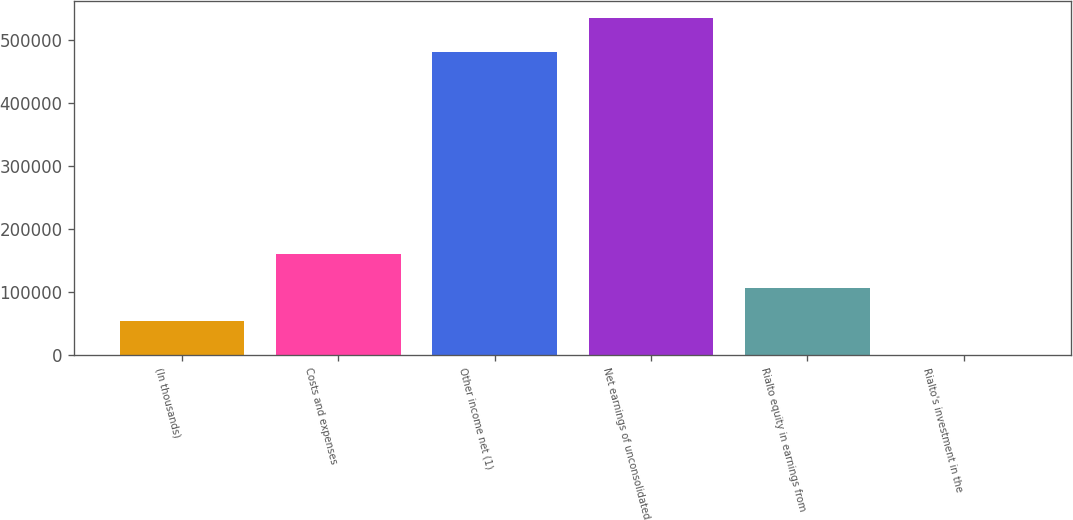<chart> <loc_0><loc_0><loc_500><loc_500><bar_chart><fcel>(In thousands)<fcel>Costs and expenses<fcel>Other income net (1)<fcel>Net earnings of unconsolidated<fcel>Rialto equity in earnings from<fcel>Rialto's investment in the<nl><fcel>53484.2<fcel>160433<fcel>479929<fcel>534752<fcel>106958<fcel>10<nl></chart> 